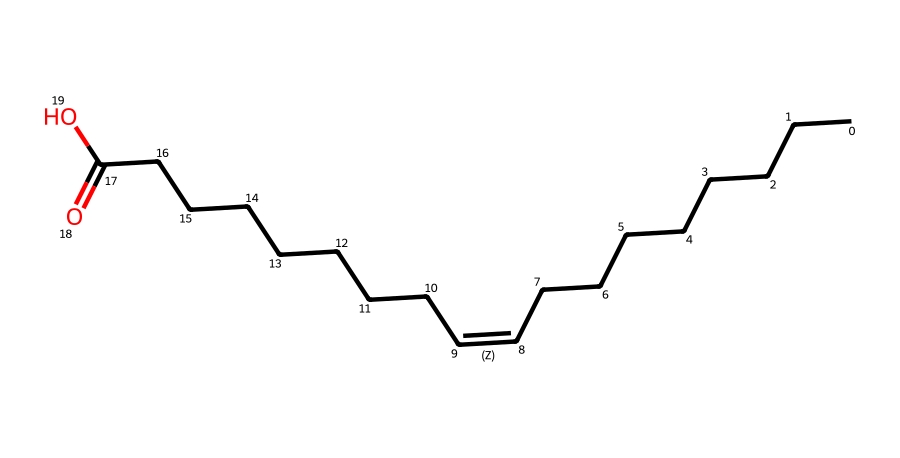How many carbon atoms are in each fatty acid? Each fatty acid contains a long hydrocarbon chain. Counting the 'C' symbols in the SMILES representation, there are 18 carbon atoms in both isomers.
Answer: eighteen What is the unsaturation point in the structure? The structure shows a double bond represented by 'C=C'. In both representations, there is one such bond that indicates unsaturation.
Answer: one Are these fatty acids saturated or unsaturated? The presence of a double bond (C=C) indicates that they are unsaturated fatty acids, as saturated fatty acids contain only single bonds.
Answer: unsaturated What distinguishes the two geometric isomers? The distinction lies in the arrangement around the double bond. The first isomer has hydrogen atoms on the same side (cis), while the second has them on opposite sides (trans).
Answer: cis and trans How many double bonds are present in these structures? Both SMILES represent a single double bond (C=C) and show the connectivity of the carbon skeleton. Therefore, there is one double bond in each isomer.
Answer: one What kind of isomerism is exhibited by these compounds? These compounds exhibit geometric isomerism due to differing spatial arrangements around the double bond (cis and trans forms).
Answer: geometric 